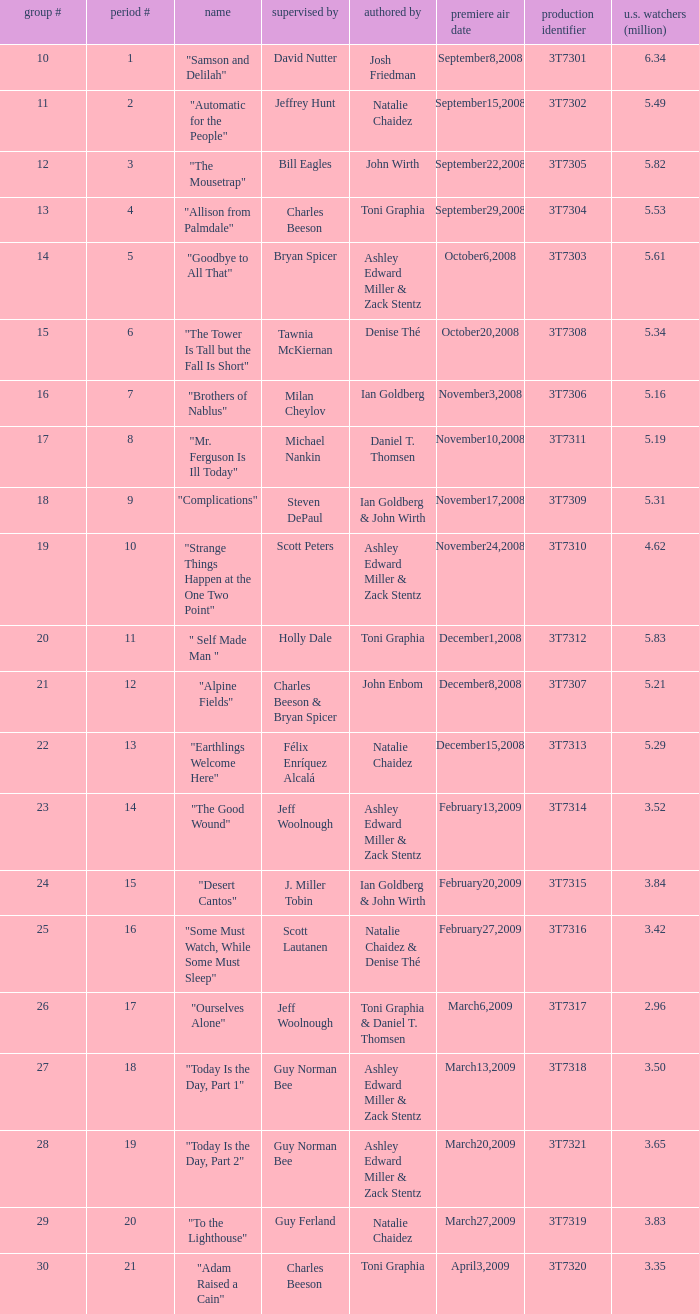How many viewers did the episode directed by David Nutter draw in? 6.34. 